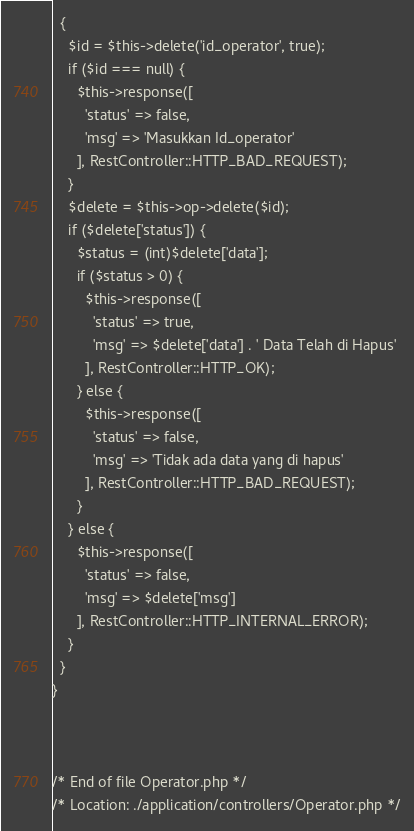Convert code to text. <code><loc_0><loc_0><loc_500><loc_500><_PHP_>  {
    $id = $this->delete('id_operator', true);
    if ($id === null) {
      $this->response([
        'status' => false,
        'msg' => 'Masukkan Id_operator'
      ], RestController::HTTP_BAD_REQUEST);
    }
    $delete = $this->op->delete($id);
    if ($delete['status']) {
      $status = (int)$delete['data'];
      if ($status > 0) {
        $this->response([
          'status' => true,
          'msg' => $delete['data'] . ' Data Telah di Hapus'
        ], RestController::HTTP_OK);
      } else {
        $this->response([
          'status' => false,
          'msg' => 'Tidak ada data yang di hapus'
        ], RestController::HTTP_BAD_REQUEST);
      }
    } else {
      $this->response([
        'status' => false,
        'msg' => $delete['msg']
      ], RestController::HTTP_INTERNAL_ERROR);
    }
  }
}



/* End of file Operator.php */
/* Location: ./application/controllers/Operator.php */</code> 